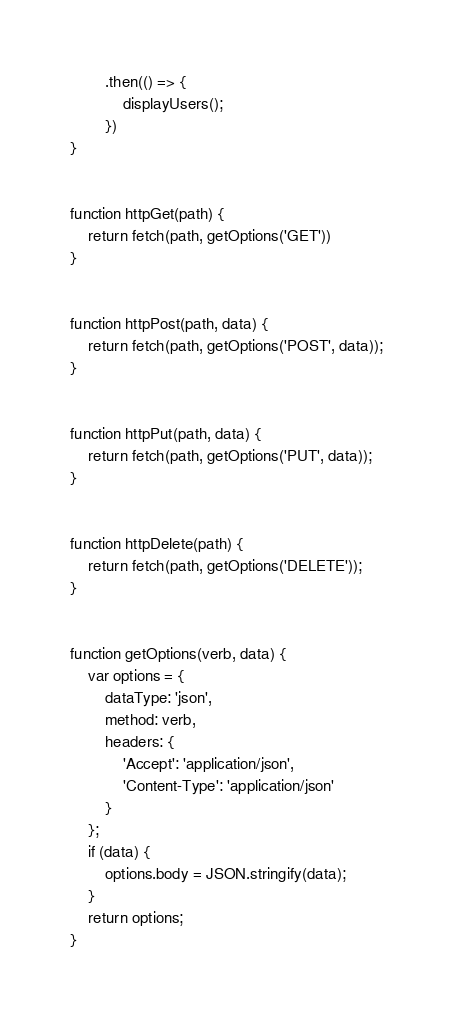<code> <loc_0><loc_0><loc_500><loc_500><_JavaScript_>        .then(() => {
            displayUsers();
        })
}


function httpGet(path) {
    return fetch(path, getOptions('GET'))
}


function httpPost(path, data) {
    return fetch(path, getOptions('POST', data));
}


function httpPut(path, data) {
    return fetch(path, getOptions('PUT', data));
}


function httpDelete(path) {
    return fetch(path, getOptions('DELETE'));
}


function getOptions(verb, data) {
    var options = {
        dataType: 'json',
        method: verb,
        headers: {
            'Accept': 'application/json',
            'Content-Type': 'application/json'
        }
    };
    if (data) {
        options.body = JSON.stringify(data);
    }
    return options;
}

</code> 